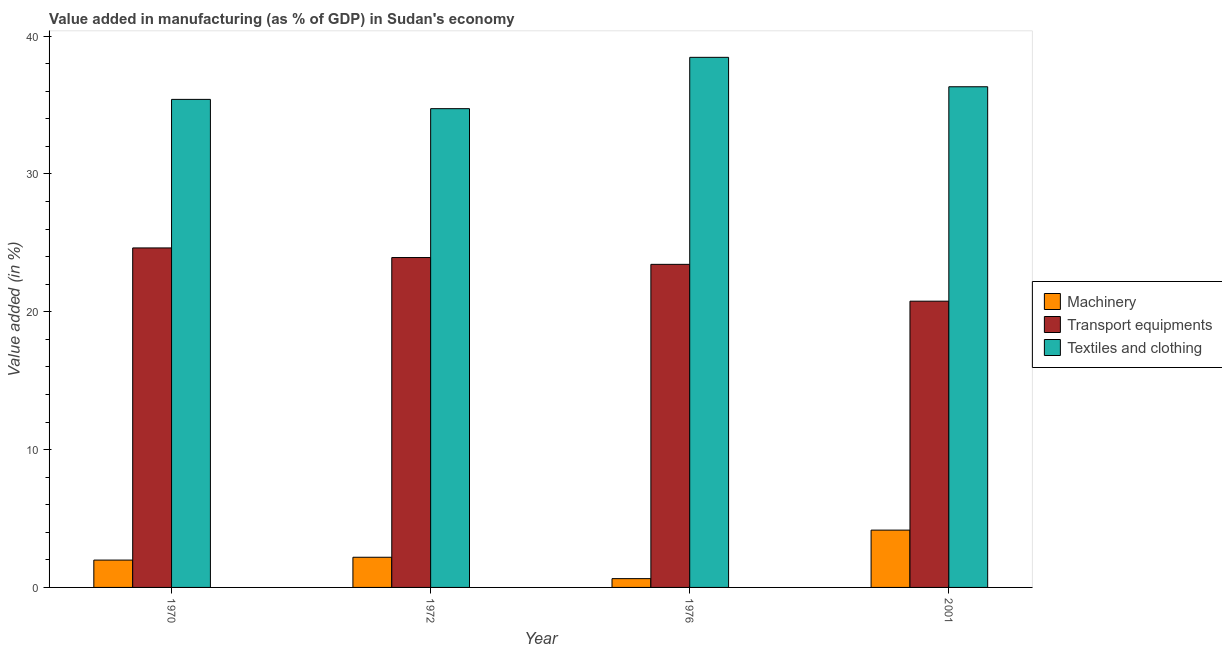How many different coloured bars are there?
Your answer should be very brief. 3. How many groups of bars are there?
Keep it short and to the point. 4. Are the number of bars per tick equal to the number of legend labels?
Keep it short and to the point. Yes. Are the number of bars on each tick of the X-axis equal?
Give a very brief answer. Yes. How many bars are there on the 1st tick from the left?
Provide a succinct answer. 3. In how many cases, is the number of bars for a given year not equal to the number of legend labels?
Your response must be concise. 0. What is the value added in manufacturing machinery in 1970?
Offer a very short reply. 1.98. Across all years, what is the maximum value added in manufacturing textile and clothing?
Your response must be concise. 38.46. Across all years, what is the minimum value added in manufacturing machinery?
Your answer should be very brief. 0.64. In which year was the value added in manufacturing machinery maximum?
Make the answer very short. 2001. In which year was the value added in manufacturing textile and clothing minimum?
Offer a terse response. 1972. What is the total value added in manufacturing transport equipments in the graph?
Make the answer very short. 92.77. What is the difference between the value added in manufacturing textile and clothing in 1970 and that in 2001?
Your response must be concise. -0.92. What is the difference between the value added in manufacturing machinery in 2001 and the value added in manufacturing transport equipments in 1972?
Provide a succinct answer. 1.97. What is the average value added in manufacturing transport equipments per year?
Ensure brevity in your answer.  23.19. In the year 1972, what is the difference between the value added in manufacturing textile and clothing and value added in manufacturing machinery?
Give a very brief answer. 0. What is the ratio of the value added in manufacturing textile and clothing in 1972 to that in 2001?
Provide a short and direct response. 0.96. Is the difference between the value added in manufacturing machinery in 1972 and 1976 greater than the difference between the value added in manufacturing textile and clothing in 1972 and 1976?
Offer a very short reply. No. What is the difference between the highest and the second highest value added in manufacturing transport equipments?
Your answer should be very brief. 0.7. What is the difference between the highest and the lowest value added in manufacturing machinery?
Your response must be concise. 3.52. In how many years, is the value added in manufacturing machinery greater than the average value added in manufacturing machinery taken over all years?
Provide a succinct answer. 1. What does the 1st bar from the left in 1976 represents?
Offer a very short reply. Machinery. What does the 2nd bar from the right in 1972 represents?
Provide a succinct answer. Transport equipments. Is it the case that in every year, the sum of the value added in manufacturing machinery and value added in manufacturing transport equipments is greater than the value added in manufacturing textile and clothing?
Make the answer very short. No. Are all the bars in the graph horizontal?
Provide a short and direct response. No. How many years are there in the graph?
Offer a very short reply. 4. Does the graph contain grids?
Ensure brevity in your answer.  No. Where does the legend appear in the graph?
Provide a short and direct response. Center right. How many legend labels are there?
Offer a terse response. 3. How are the legend labels stacked?
Ensure brevity in your answer.  Vertical. What is the title of the graph?
Offer a very short reply. Value added in manufacturing (as % of GDP) in Sudan's economy. What is the label or title of the X-axis?
Keep it short and to the point. Year. What is the label or title of the Y-axis?
Offer a very short reply. Value added (in %). What is the Value added (in %) in Machinery in 1970?
Make the answer very short. 1.98. What is the Value added (in %) in Transport equipments in 1970?
Ensure brevity in your answer.  24.63. What is the Value added (in %) of Textiles and clothing in 1970?
Offer a very short reply. 35.41. What is the Value added (in %) in Machinery in 1972?
Keep it short and to the point. 2.19. What is the Value added (in %) of Transport equipments in 1972?
Offer a very short reply. 23.93. What is the Value added (in %) in Textiles and clothing in 1972?
Offer a very short reply. 34.73. What is the Value added (in %) in Machinery in 1976?
Your response must be concise. 0.64. What is the Value added (in %) of Transport equipments in 1976?
Your answer should be compact. 23.44. What is the Value added (in %) in Textiles and clothing in 1976?
Offer a very short reply. 38.46. What is the Value added (in %) of Machinery in 2001?
Keep it short and to the point. 4.16. What is the Value added (in %) in Transport equipments in 2001?
Your answer should be very brief. 20.77. What is the Value added (in %) in Textiles and clothing in 2001?
Offer a terse response. 36.32. Across all years, what is the maximum Value added (in %) of Machinery?
Provide a succinct answer. 4.16. Across all years, what is the maximum Value added (in %) in Transport equipments?
Offer a terse response. 24.63. Across all years, what is the maximum Value added (in %) in Textiles and clothing?
Provide a succinct answer. 38.46. Across all years, what is the minimum Value added (in %) in Machinery?
Ensure brevity in your answer.  0.64. Across all years, what is the minimum Value added (in %) of Transport equipments?
Make the answer very short. 20.77. Across all years, what is the minimum Value added (in %) of Textiles and clothing?
Your answer should be compact. 34.73. What is the total Value added (in %) of Machinery in the graph?
Keep it short and to the point. 8.97. What is the total Value added (in %) of Transport equipments in the graph?
Your answer should be very brief. 92.77. What is the total Value added (in %) of Textiles and clothing in the graph?
Provide a succinct answer. 144.93. What is the difference between the Value added (in %) of Machinery in 1970 and that in 1972?
Provide a succinct answer. -0.21. What is the difference between the Value added (in %) of Transport equipments in 1970 and that in 1972?
Your response must be concise. 0.7. What is the difference between the Value added (in %) in Textiles and clothing in 1970 and that in 1972?
Make the answer very short. 0.67. What is the difference between the Value added (in %) in Machinery in 1970 and that in 1976?
Make the answer very short. 1.35. What is the difference between the Value added (in %) of Transport equipments in 1970 and that in 1976?
Your response must be concise. 1.19. What is the difference between the Value added (in %) of Textiles and clothing in 1970 and that in 1976?
Offer a very short reply. -3.05. What is the difference between the Value added (in %) in Machinery in 1970 and that in 2001?
Offer a terse response. -2.17. What is the difference between the Value added (in %) in Transport equipments in 1970 and that in 2001?
Offer a terse response. 3.86. What is the difference between the Value added (in %) of Textiles and clothing in 1970 and that in 2001?
Give a very brief answer. -0.92. What is the difference between the Value added (in %) in Machinery in 1972 and that in 1976?
Ensure brevity in your answer.  1.55. What is the difference between the Value added (in %) of Transport equipments in 1972 and that in 1976?
Ensure brevity in your answer.  0.49. What is the difference between the Value added (in %) of Textiles and clothing in 1972 and that in 1976?
Provide a succinct answer. -3.72. What is the difference between the Value added (in %) in Machinery in 1972 and that in 2001?
Offer a very short reply. -1.97. What is the difference between the Value added (in %) of Transport equipments in 1972 and that in 2001?
Your answer should be very brief. 3.17. What is the difference between the Value added (in %) in Textiles and clothing in 1972 and that in 2001?
Provide a short and direct response. -1.59. What is the difference between the Value added (in %) in Machinery in 1976 and that in 2001?
Your answer should be compact. -3.52. What is the difference between the Value added (in %) of Transport equipments in 1976 and that in 2001?
Give a very brief answer. 2.67. What is the difference between the Value added (in %) in Textiles and clothing in 1976 and that in 2001?
Your response must be concise. 2.14. What is the difference between the Value added (in %) of Machinery in 1970 and the Value added (in %) of Transport equipments in 1972?
Offer a very short reply. -21.95. What is the difference between the Value added (in %) of Machinery in 1970 and the Value added (in %) of Textiles and clothing in 1972?
Provide a short and direct response. -32.75. What is the difference between the Value added (in %) of Transport equipments in 1970 and the Value added (in %) of Textiles and clothing in 1972?
Provide a succinct answer. -10.1. What is the difference between the Value added (in %) of Machinery in 1970 and the Value added (in %) of Transport equipments in 1976?
Ensure brevity in your answer.  -21.46. What is the difference between the Value added (in %) in Machinery in 1970 and the Value added (in %) in Textiles and clothing in 1976?
Give a very brief answer. -36.48. What is the difference between the Value added (in %) in Transport equipments in 1970 and the Value added (in %) in Textiles and clothing in 1976?
Your answer should be compact. -13.83. What is the difference between the Value added (in %) of Machinery in 1970 and the Value added (in %) of Transport equipments in 2001?
Provide a succinct answer. -18.78. What is the difference between the Value added (in %) of Machinery in 1970 and the Value added (in %) of Textiles and clothing in 2001?
Provide a short and direct response. -34.34. What is the difference between the Value added (in %) of Transport equipments in 1970 and the Value added (in %) of Textiles and clothing in 2001?
Your answer should be compact. -11.69. What is the difference between the Value added (in %) in Machinery in 1972 and the Value added (in %) in Transport equipments in 1976?
Offer a terse response. -21.25. What is the difference between the Value added (in %) of Machinery in 1972 and the Value added (in %) of Textiles and clothing in 1976?
Give a very brief answer. -36.27. What is the difference between the Value added (in %) in Transport equipments in 1972 and the Value added (in %) in Textiles and clothing in 1976?
Provide a short and direct response. -14.53. What is the difference between the Value added (in %) in Machinery in 1972 and the Value added (in %) in Transport equipments in 2001?
Ensure brevity in your answer.  -18.58. What is the difference between the Value added (in %) of Machinery in 1972 and the Value added (in %) of Textiles and clothing in 2001?
Provide a succinct answer. -34.14. What is the difference between the Value added (in %) of Transport equipments in 1972 and the Value added (in %) of Textiles and clothing in 2001?
Your response must be concise. -12.39. What is the difference between the Value added (in %) of Machinery in 1976 and the Value added (in %) of Transport equipments in 2001?
Offer a terse response. -20.13. What is the difference between the Value added (in %) in Machinery in 1976 and the Value added (in %) in Textiles and clothing in 2001?
Offer a very short reply. -35.69. What is the difference between the Value added (in %) in Transport equipments in 1976 and the Value added (in %) in Textiles and clothing in 2001?
Your response must be concise. -12.89. What is the average Value added (in %) of Machinery per year?
Ensure brevity in your answer.  2.24. What is the average Value added (in %) in Transport equipments per year?
Your response must be concise. 23.19. What is the average Value added (in %) of Textiles and clothing per year?
Your answer should be very brief. 36.23. In the year 1970, what is the difference between the Value added (in %) of Machinery and Value added (in %) of Transport equipments?
Offer a very short reply. -22.65. In the year 1970, what is the difference between the Value added (in %) in Machinery and Value added (in %) in Textiles and clothing?
Make the answer very short. -33.43. In the year 1970, what is the difference between the Value added (in %) of Transport equipments and Value added (in %) of Textiles and clothing?
Offer a very short reply. -10.78. In the year 1972, what is the difference between the Value added (in %) of Machinery and Value added (in %) of Transport equipments?
Your answer should be compact. -21.75. In the year 1972, what is the difference between the Value added (in %) in Machinery and Value added (in %) in Textiles and clothing?
Offer a very short reply. -32.55. In the year 1972, what is the difference between the Value added (in %) in Transport equipments and Value added (in %) in Textiles and clothing?
Provide a short and direct response. -10.8. In the year 1976, what is the difference between the Value added (in %) of Machinery and Value added (in %) of Transport equipments?
Your answer should be very brief. -22.8. In the year 1976, what is the difference between the Value added (in %) in Machinery and Value added (in %) in Textiles and clothing?
Your answer should be very brief. -37.82. In the year 1976, what is the difference between the Value added (in %) of Transport equipments and Value added (in %) of Textiles and clothing?
Your response must be concise. -15.02. In the year 2001, what is the difference between the Value added (in %) of Machinery and Value added (in %) of Transport equipments?
Keep it short and to the point. -16.61. In the year 2001, what is the difference between the Value added (in %) of Machinery and Value added (in %) of Textiles and clothing?
Your response must be concise. -32.17. In the year 2001, what is the difference between the Value added (in %) of Transport equipments and Value added (in %) of Textiles and clothing?
Offer a very short reply. -15.56. What is the ratio of the Value added (in %) in Machinery in 1970 to that in 1972?
Offer a terse response. 0.91. What is the ratio of the Value added (in %) in Transport equipments in 1970 to that in 1972?
Your response must be concise. 1.03. What is the ratio of the Value added (in %) of Textiles and clothing in 1970 to that in 1972?
Your answer should be compact. 1.02. What is the ratio of the Value added (in %) of Machinery in 1970 to that in 1976?
Give a very brief answer. 3.11. What is the ratio of the Value added (in %) in Transport equipments in 1970 to that in 1976?
Your answer should be compact. 1.05. What is the ratio of the Value added (in %) of Textiles and clothing in 1970 to that in 1976?
Offer a terse response. 0.92. What is the ratio of the Value added (in %) of Machinery in 1970 to that in 2001?
Your answer should be compact. 0.48. What is the ratio of the Value added (in %) in Transport equipments in 1970 to that in 2001?
Your answer should be very brief. 1.19. What is the ratio of the Value added (in %) of Textiles and clothing in 1970 to that in 2001?
Provide a succinct answer. 0.97. What is the ratio of the Value added (in %) in Machinery in 1972 to that in 1976?
Your response must be concise. 3.43. What is the ratio of the Value added (in %) in Transport equipments in 1972 to that in 1976?
Ensure brevity in your answer.  1.02. What is the ratio of the Value added (in %) in Textiles and clothing in 1972 to that in 1976?
Give a very brief answer. 0.9. What is the ratio of the Value added (in %) of Machinery in 1972 to that in 2001?
Provide a succinct answer. 0.53. What is the ratio of the Value added (in %) in Transport equipments in 1972 to that in 2001?
Offer a very short reply. 1.15. What is the ratio of the Value added (in %) in Textiles and clothing in 1972 to that in 2001?
Your answer should be very brief. 0.96. What is the ratio of the Value added (in %) of Machinery in 1976 to that in 2001?
Keep it short and to the point. 0.15. What is the ratio of the Value added (in %) of Transport equipments in 1976 to that in 2001?
Provide a succinct answer. 1.13. What is the ratio of the Value added (in %) of Textiles and clothing in 1976 to that in 2001?
Provide a succinct answer. 1.06. What is the difference between the highest and the second highest Value added (in %) in Machinery?
Keep it short and to the point. 1.97. What is the difference between the highest and the second highest Value added (in %) in Transport equipments?
Your response must be concise. 0.7. What is the difference between the highest and the second highest Value added (in %) of Textiles and clothing?
Offer a very short reply. 2.14. What is the difference between the highest and the lowest Value added (in %) of Machinery?
Ensure brevity in your answer.  3.52. What is the difference between the highest and the lowest Value added (in %) in Transport equipments?
Provide a short and direct response. 3.86. What is the difference between the highest and the lowest Value added (in %) of Textiles and clothing?
Your response must be concise. 3.72. 